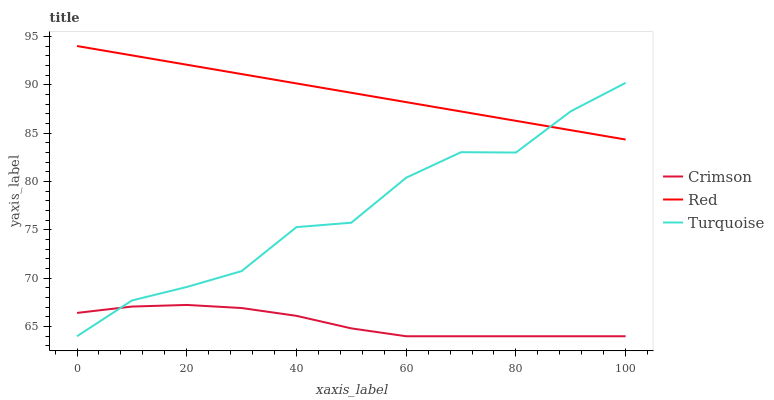Does Crimson have the minimum area under the curve?
Answer yes or no. Yes. Does Red have the maximum area under the curve?
Answer yes or no. Yes. Does Turquoise have the minimum area under the curve?
Answer yes or no. No. Does Turquoise have the maximum area under the curve?
Answer yes or no. No. Is Red the smoothest?
Answer yes or no. Yes. Is Turquoise the roughest?
Answer yes or no. Yes. Is Turquoise the smoothest?
Answer yes or no. No. Is Red the roughest?
Answer yes or no. No. Does Crimson have the lowest value?
Answer yes or no. Yes. Does Red have the lowest value?
Answer yes or no. No. Does Red have the highest value?
Answer yes or no. Yes. Does Turquoise have the highest value?
Answer yes or no. No. Is Crimson less than Red?
Answer yes or no. Yes. Is Red greater than Crimson?
Answer yes or no. Yes. Does Turquoise intersect Crimson?
Answer yes or no. Yes. Is Turquoise less than Crimson?
Answer yes or no. No. Is Turquoise greater than Crimson?
Answer yes or no. No. Does Crimson intersect Red?
Answer yes or no. No. 